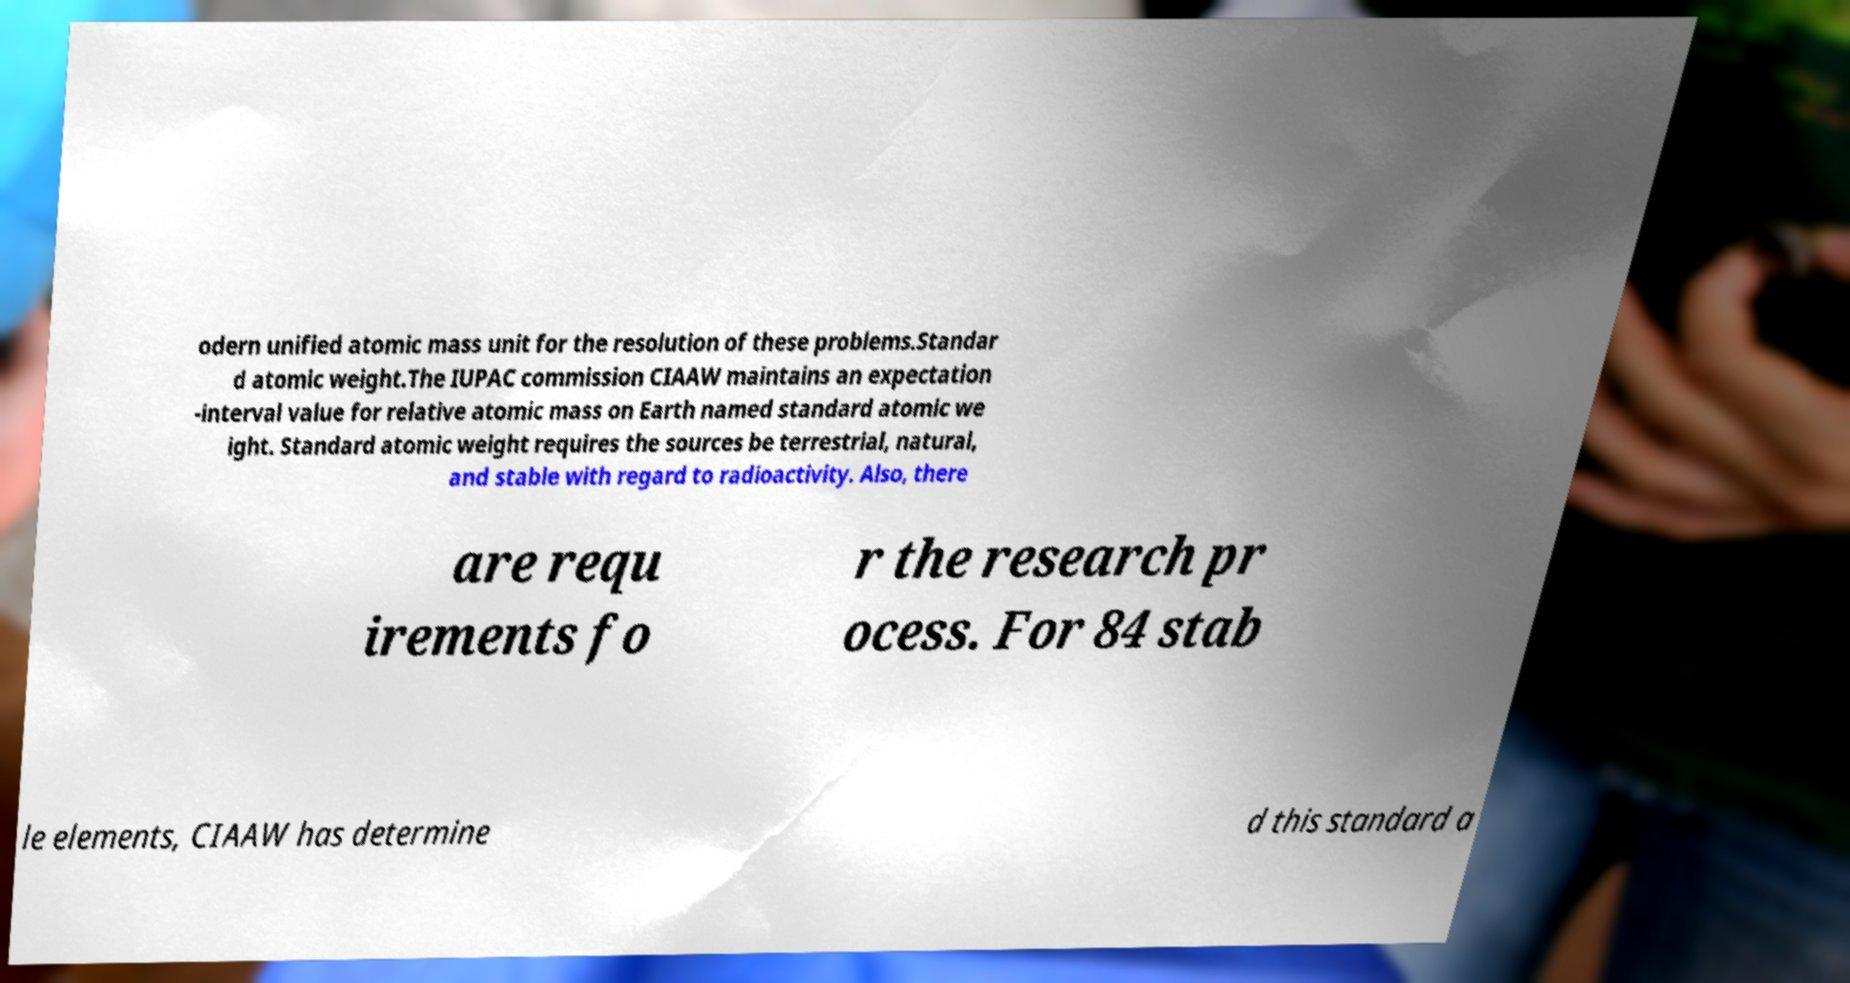Please identify and transcribe the text found in this image. odern unified atomic mass unit for the resolution of these problems.Standar d atomic weight.The IUPAC commission CIAAW maintains an expectation -interval value for relative atomic mass on Earth named standard atomic we ight. Standard atomic weight requires the sources be terrestrial, natural, and stable with regard to radioactivity. Also, there are requ irements fo r the research pr ocess. For 84 stab le elements, CIAAW has determine d this standard a 